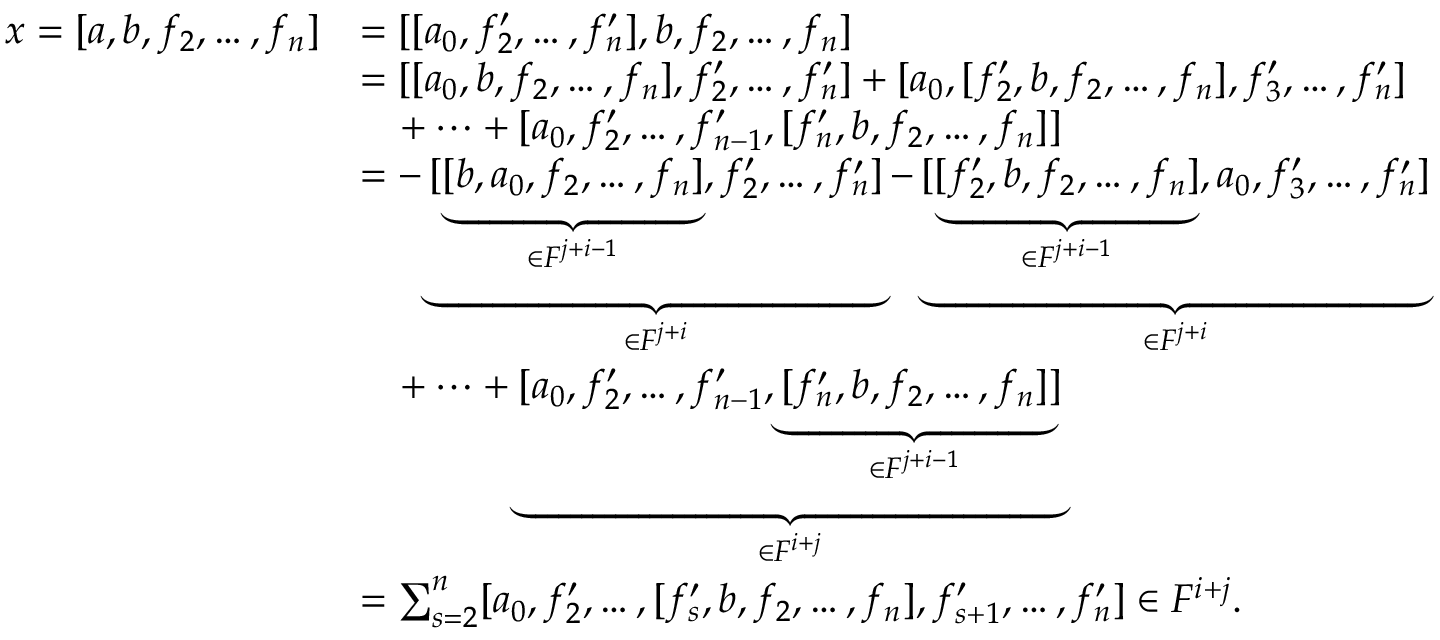Convert formula to latex. <formula><loc_0><loc_0><loc_500><loc_500>\begin{array} { r l } { x = [ a , b , f _ { 2 } , \dots , f _ { n } ] } & { = [ [ a _ { 0 } , f _ { 2 } ^ { \prime } , \dots , f _ { n } ^ { \prime } ] , b , f _ { 2 } , \dots , f _ { n } ] } \\ & { = [ [ a _ { 0 } , b , f _ { 2 } , \dots , f _ { n } ] , f _ { 2 } ^ { \prime } , \dots , f _ { n } ^ { \prime } ] + [ a _ { 0 } , [ f _ { 2 } ^ { \prime } , b , f _ { 2 } , \dots , f _ { n } ] , f _ { 3 } ^ { \prime } , \dots , f _ { n } ^ { \prime } ] } \\ & { \quad + \dots + [ a _ { 0 } , f _ { 2 } ^ { \prime } , \dots , f _ { n - 1 } ^ { \prime } , [ f _ { n } ^ { \prime } , b , f _ { 2 } , \dots , f _ { n } ] ] } \\ & { = - \underbrace { [ \underbrace { [ b , a _ { 0 } , f _ { 2 } , \dots , f _ { n } ] } _ { \in F ^ { j + i - 1 } } , f _ { 2 } ^ { \prime } , \dots , f _ { n } ^ { \prime } ] } _ { \in F ^ { j + i } } - \underbrace { [ \underbrace { [ f _ { 2 } ^ { \prime } , b , f _ { 2 } , \dots , f _ { n } ] } _ { \in F ^ { j + i - 1 } } , a _ { 0 } , f _ { 3 } ^ { \prime } , \dots , f _ { n } ^ { \prime } ] } _ { \in F ^ { j + i } } } \\ & { \quad + \dots + \underbrace { [ a _ { 0 } , f _ { 2 } ^ { \prime } , \dots , f _ { n - 1 } ^ { \prime } , \underbrace { [ f _ { n } ^ { \prime } , b , f _ { 2 } , \dots , f _ { n } ] } _ { \in F ^ { j + i - 1 } } ] } _ { \in F ^ { i + j } } } \\ & { = \sum _ { s = 2 } ^ { n } [ a _ { 0 } , f _ { 2 } ^ { \prime } , \dots , [ f _ { s } ^ { \prime } , b , f _ { 2 } , \dots , f _ { n } ] , f _ { s + 1 } ^ { \prime } , \dots , f _ { n } ^ { \prime } ] \in F ^ { i + j } . } \end{array}</formula> 